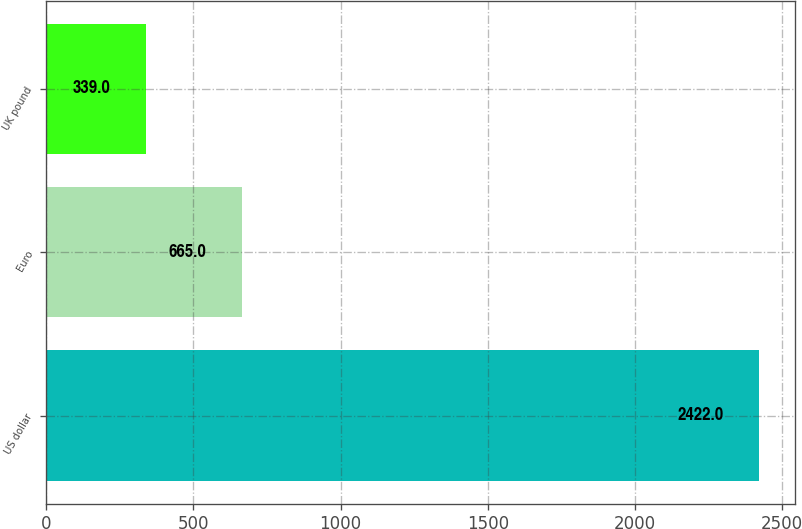Convert chart to OTSL. <chart><loc_0><loc_0><loc_500><loc_500><bar_chart><fcel>US dollar<fcel>Euro<fcel>UK pound<nl><fcel>2422<fcel>665<fcel>339<nl></chart> 